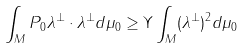Convert formula to latex. <formula><loc_0><loc_0><loc_500><loc_500>\int _ { M } P _ { 0 } \lambda ^ { \perp } \cdot \lambda ^ { \perp } d \mu _ { 0 } \geq \Upsilon \int _ { M } ( \lambda ^ { \perp } ) ^ { 2 } d \mu _ { 0 }</formula> 